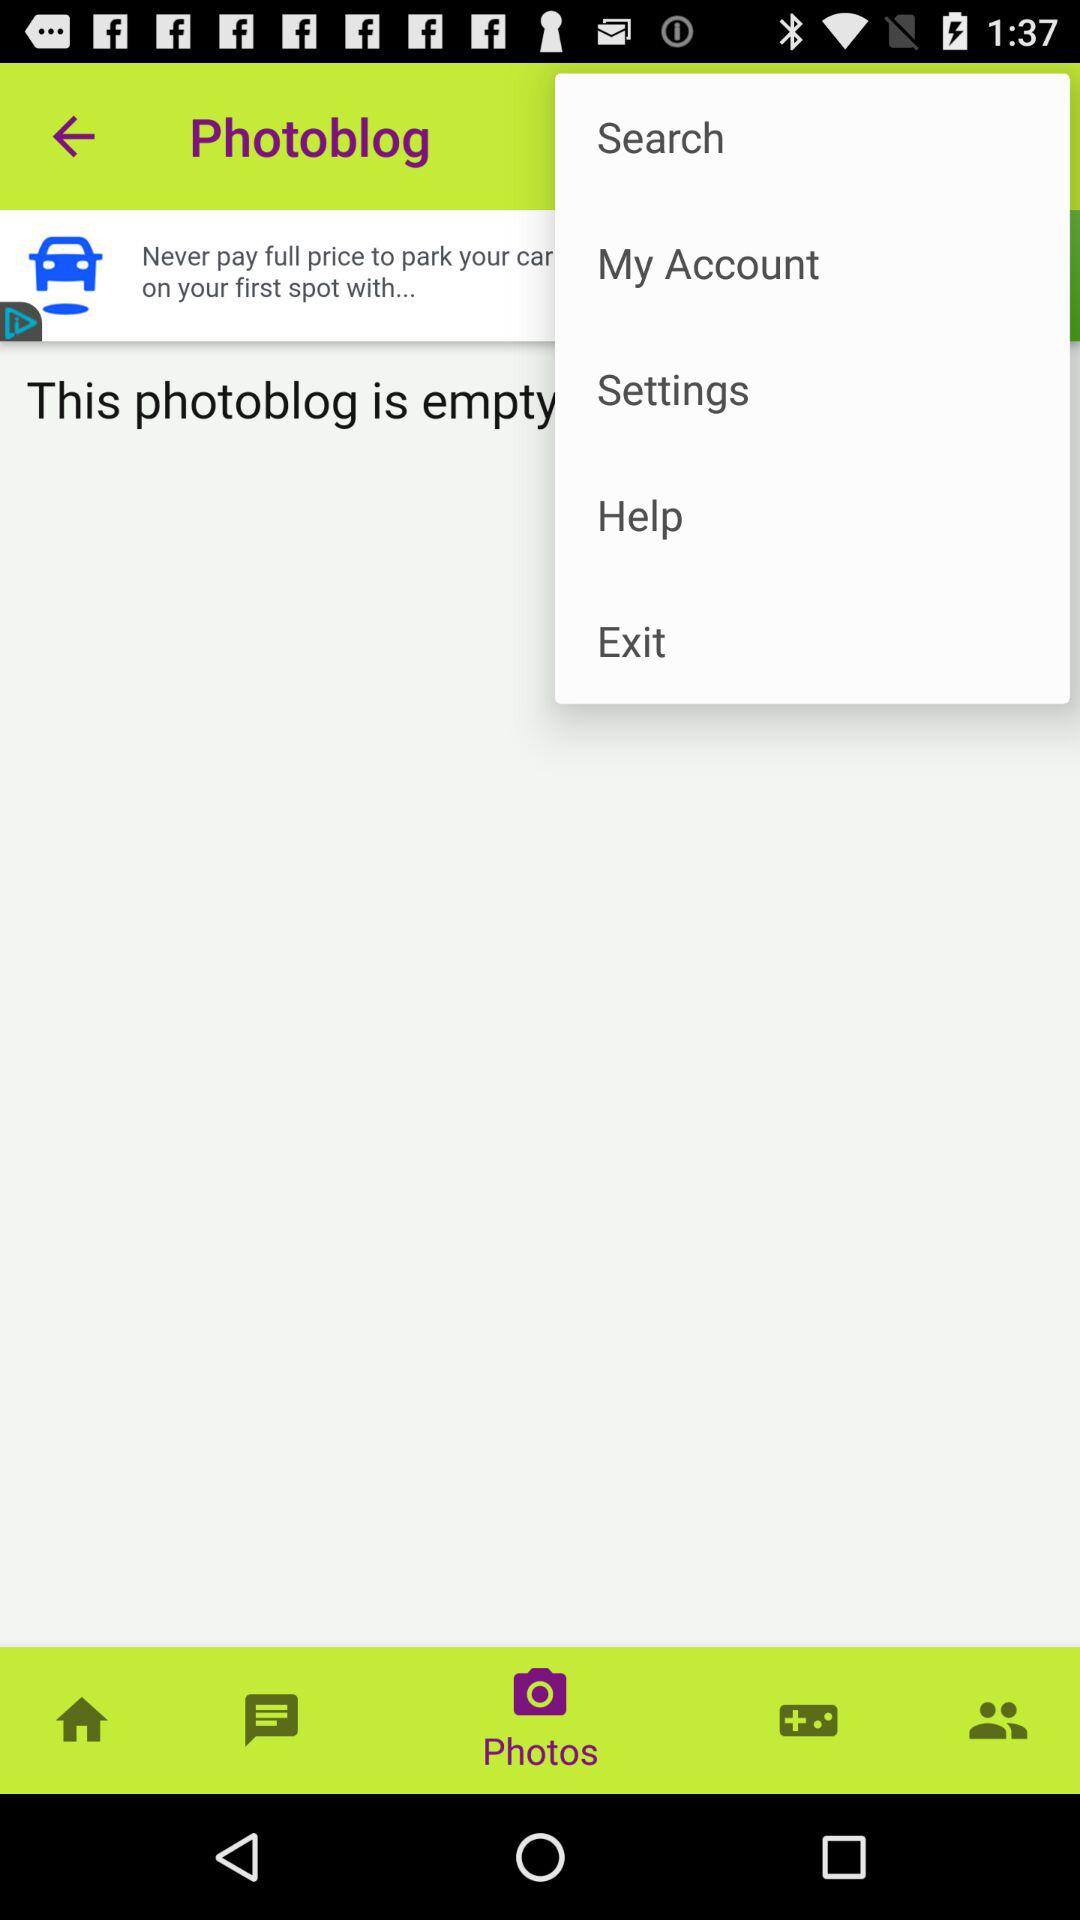What is the selected tab? The selected tab is "Photos". 